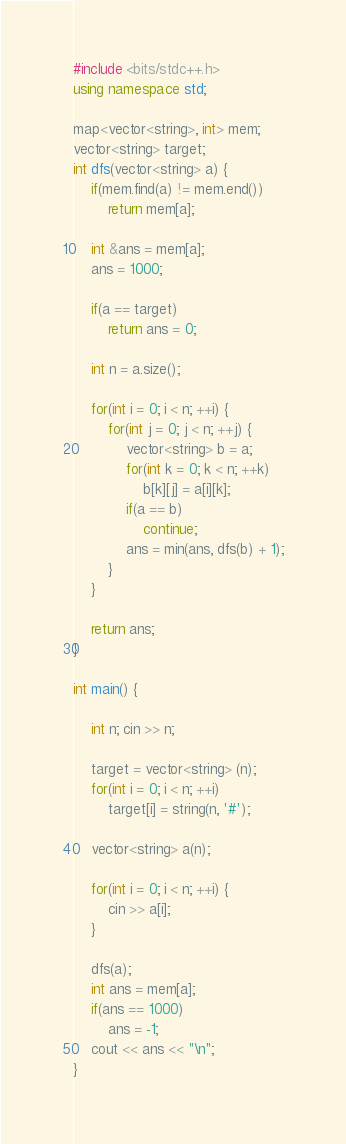<code> <loc_0><loc_0><loc_500><loc_500><_C++_>#include <bits/stdc++.h>
using namespace std;

map<vector<string>, int> mem;
vector<string> target;
int dfs(vector<string> a) {
    if(mem.find(a) != mem.end())
        return mem[a];

    int &ans = mem[a];
    ans = 1000;
    
    if(a == target)
        return ans = 0;

    int n = a.size();

    for(int i = 0; i < n; ++i) {
        for(int j = 0; j < n; ++j) {
            vector<string> b = a;
            for(int k = 0; k < n; ++k)
                b[k][j] = a[i][k];
            if(a == b)
                continue;
            ans = min(ans, dfs(b) + 1);
        }
    }

    return ans;
}

int main() {

    int n; cin >> n;
    
    target = vector<string> (n);
    for(int i = 0; i < n; ++i)
        target[i] = string(n, '#');

    vector<string> a(n);

    for(int i = 0; i < n; ++i) {
        cin >> a[i];
    }
    
    dfs(a);
    int ans = mem[a];
    if(ans == 1000)
        ans = -1;
    cout << ans << "\n";
}</code> 